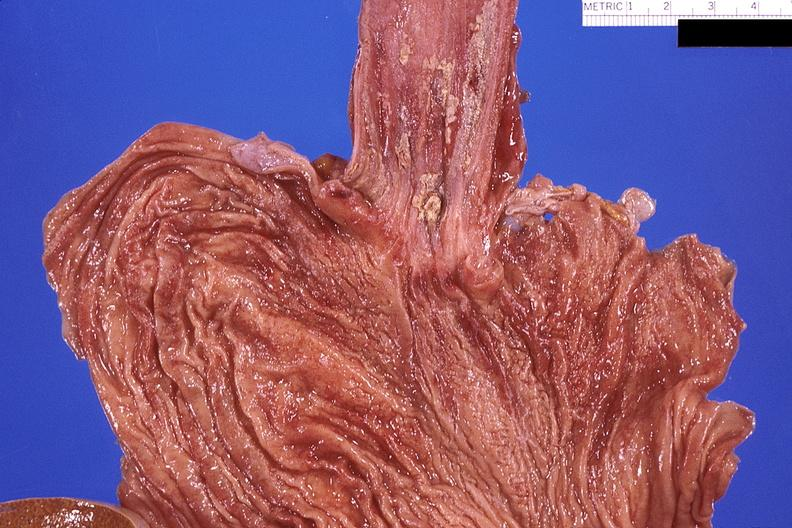where does this belong to?
Answer the question using a single word or phrase. Gastrointestinal system 